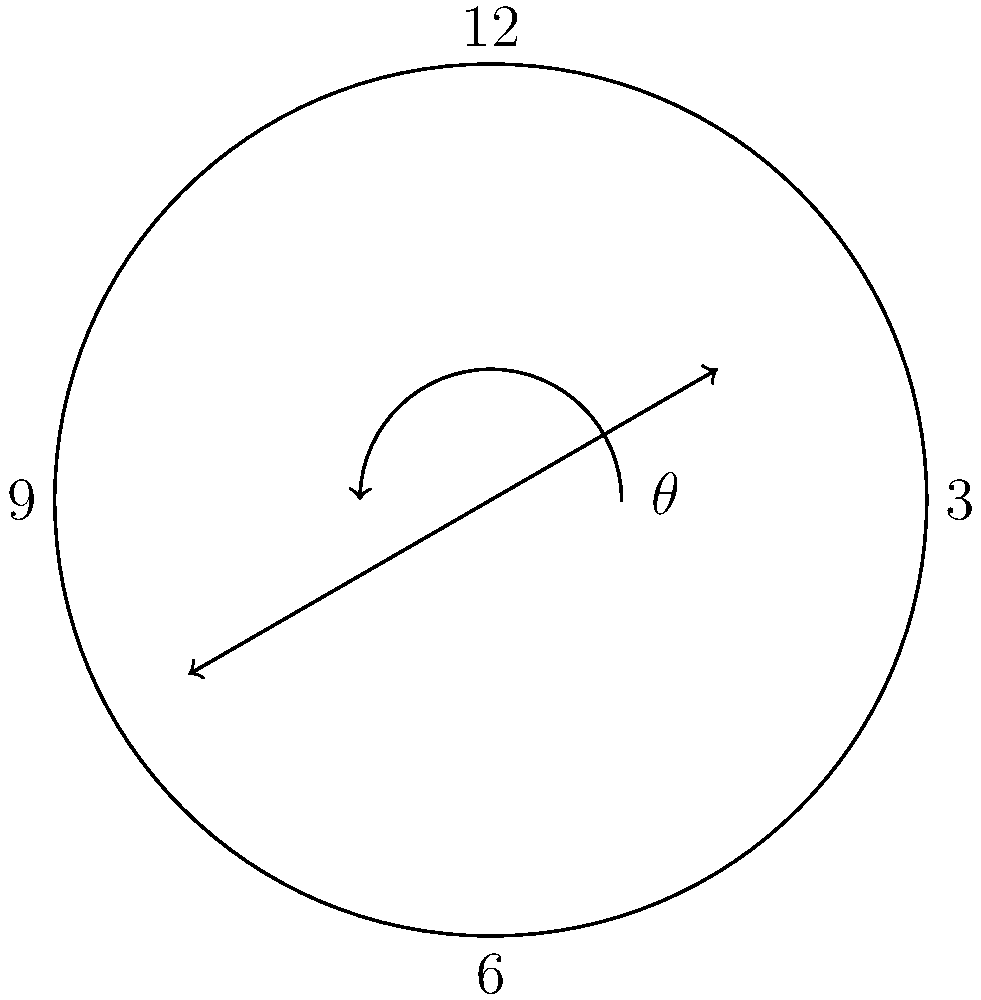You're helping your child understand clock hands and angles. At 1:42, what is the angle between the hour and minute hands? (Hint: Consider that the hour hand moves slightly past 1 o'clock.) Let's approach this step-by-step:

1) First, let's calculate the angle for the minute hand:
   - There are 360° in a circle and 60 minutes in an hour.
   - So, each minute represents 360° ÷ 60 = 6° of rotation.
   - At 42 minutes, the minute hand has rotated: 42 × 6° = 252°

2) Now, for the hour hand:
   - There are 12 hours in a complete rotation (360°).
   - So, each hour represents 360° ÷ 12 = 30° of rotation.
   - However, the hour hand also moves slightly between hours.
   - At 42 minutes past the hour, it has moved an additional:
     42 ÷ 60 × 30° = 21°
   - So the total angle for the hour hand is: 30° + 21° = 51°

3) The angle between the hands is the absolute difference:
   |252° - 51°| = 201°

4) However, we want the smaller angle between the hands.
   If this angle is greater than 180°, we subtract it from 360°.
   360° - 201° = 159°

Therefore, the angle between the hour and minute hands at 1:42 is 159°.
Answer: 159° 